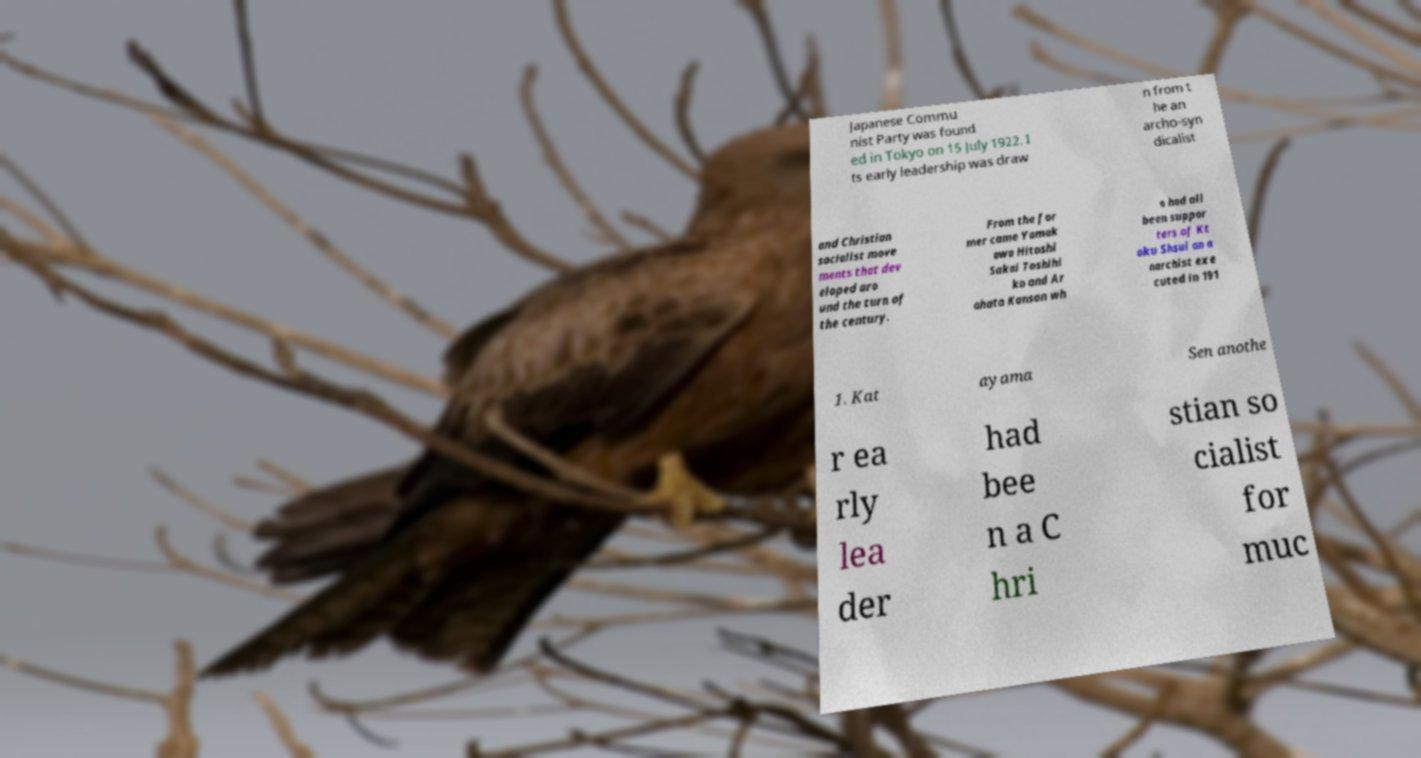Could you extract and type out the text from this image? Japanese Commu nist Party was found ed in Tokyo on 15 July 1922. I ts early leadership was draw n from t he an archo-syn dicalist and Christian socialist move ments that dev eloped aro und the turn of the century. From the for mer came Yamak awa Hitoshi Sakai Toshihi ko and Ar ahata Kanson wh o had all been suppor ters of Kt oku Shsui an a narchist exe cuted in 191 1. Kat ayama Sen anothe r ea rly lea der had bee n a C hri stian so cialist for muc 